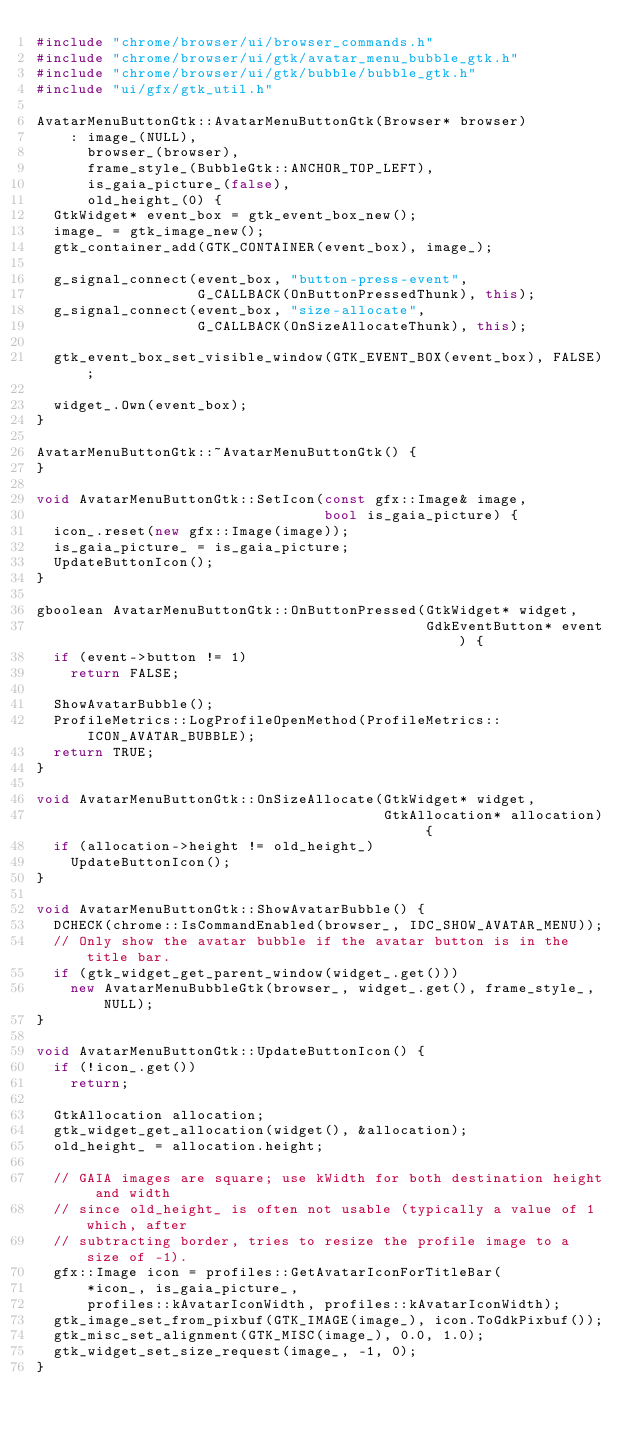<code> <loc_0><loc_0><loc_500><loc_500><_C++_>#include "chrome/browser/ui/browser_commands.h"
#include "chrome/browser/ui/gtk/avatar_menu_bubble_gtk.h"
#include "chrome/browser/ui/gtk/bubble/bubble_gtk.h"
#include "ui/gfx/gtk_util.h"

AvatarMenuButtonGtk::AvatarMenuButtonGtk(Browser* browser)
    : image_(NULL),
      browser_(browser),
      frame_style_(BubbleGtk::ANCHOR_TOP_LEFT),
      is_gaia_picture_(false),
      old_height_(0) {
  GtkWidget* event_box = gtk_event_box_new();
  image_ = gtk_image_new();
  gtk_container_add(GTK_CONTAINER(event_box), image_);

  g_signal_connect(event_box, "button-press-event",
                   G_CALLBACK(OnButtonPressedThunk), this);
  g_signal_connect(event_box, "size-allocate",
                   G_CALLBACK(OnSizeAllocateThunk), this);

  gtk_event_box_set_visible_window(GTK_EVENT_BOX(event_box), FALSE);

  widget_.Own(event_box);
}

AvatarMenuButtonGtk::~AvatarMenuButtonGtk() {
}

void AvatarMenuButtonGtk::SetIcon(const gfx::Image& image,
                                  bool is_gaia_picture) {
  icon_.reset(new gfx::Image(image));
  is_gaia_picture_ = is_gaia_picture;
  UpdateButtonIcon();
}

gboolean AvatarMenuButtonGtk::OnButtonPressed(GtkWidget* widget,
                                              GdkEventButton* event) {
  if (event->button != 1)
    return FALSE;

  ShowAvatarBubble();
  ProfileMetrics::LogProfileOpenMethod(ProfileMetrics::ICON_AVATAR_BUBBLE);
  return TRUE;
}

void AvatarMenuButtonGtk::OnSizeAllocate(GtkWidget* widget,
                                         GtkAllocation* allocation) {
  if (allocation->height != old_height_)
    UpdateButtonIcon();
}

void AvatarMenuButtonGtk::ShowAvatarBubble() {
  DCHECK(chrome::IsCommandEnabled(browser_, IDC_SHOW_AVATAR_MENU));
  // Only show the avatar bubble if the avatar button is in the title bar.
  if (gtk_widget_get_parent_window(widget_.get()))
    new AvatarMenuBubbleGtk(browser_, widget_.get(), frame_style_, NULL);
}

void AvatarMenuButtonGtk::UpdateButtonIcon() {
  if (!icon_.get())
    return;

  GtkAllocation allocation;
  gtk_widget_get_allocation(widget(), &allocation);
  old_height_ = allocation.height;

  // GAIA images are square; use kWidth for both destination height and width
  // since old_height_ is often not usable (typically a value of 1 which, after
  // subtracting border, tries to resize the profile image to a size of -1).
  gfx::Image icon = profiles::GetAvatarIconForTitleBar(
      *icon_, is_gaia_picture_,
      profiles::kAvatarIconWidth, profiles::kAvatarIconWidth);
  gtk_image_set_from_pixbuf(GTK_IMAGE(image_), icon.ToGdkPixbuf());
  gtk_misc_set_alignment(GTK_MISC(image_), 0.0, 1.0);
  gtk_widget_set_size_request(image_, -1, 0);
}
</code> 